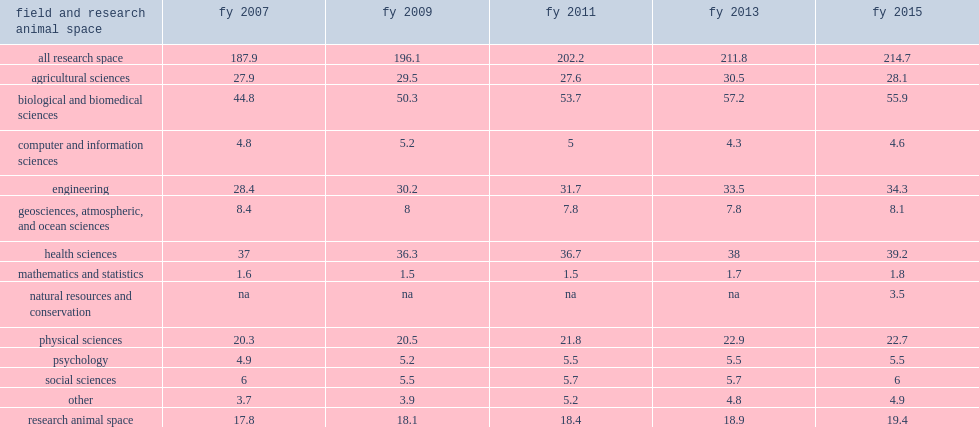How many million dollars did total research space increase net assignable square feet (nasf) over fy 2013-2015 period? 2.9. How many million dollars was total research space net assignable square feet (nasf) in fy 2013? 211.8. How many million dollars was total research space net assignable square feet (nasf) in fy 2015? 214.7. How many million dollars did biological and biomedical sciences total fewer nasf of research space in fy 2015 than in fy 2013? 1.3. Biological and biomedical sciences totaled 1.3 million fewer nasf of research space in fy 2015 than in fy 2013, how many percent of a decrease? 0.023256. 